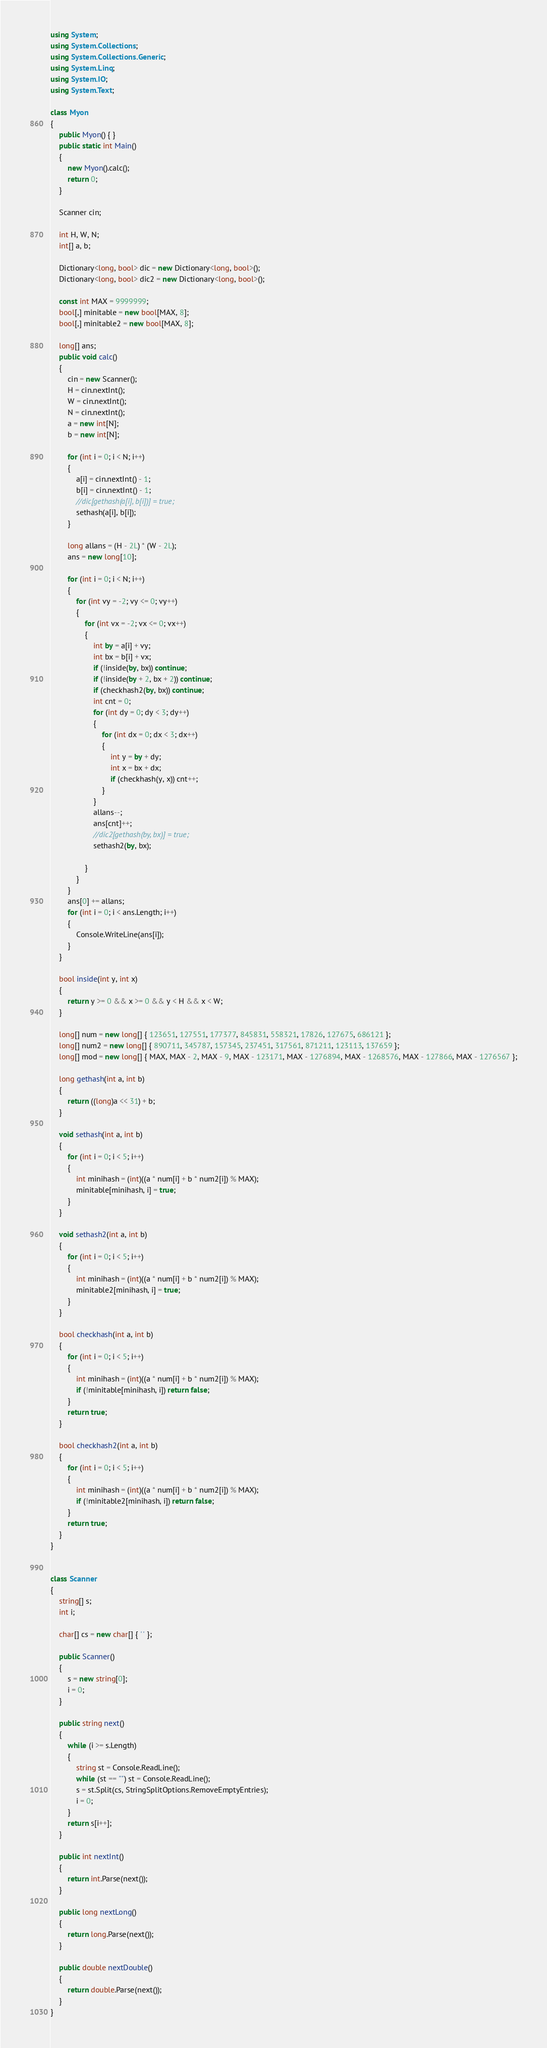Convert code to text. <code><loc_0><loc_0><loc_500><loc_500><_C#_>using System;
using System.Collections;
using System.Collections.Generic;
using System.Linq;
using System.IO;
using System.Text;

class Myon
{
    public Myon() { }
    public static int Main()
    {
        new Myon().calc();
        return 0;
    }

    Scanner cin;

    int H, W, N;
    int[] a, b;

    Dictionary<long, bool> dic = new Dictionary<long, bool>();
    Dictionary<long, bool> dic2 = new Dictionary<long, bool>();

    const int MAX = 9999999;
    bool[,] minitable = new bool[MAX, 8];
    bool[,] minitable2 = new bool[MAX, 8];

    long[] ans;
    public void calc()
    {
        cin = new Scanner();
        H = cin.nextInt();
        W = cin.nextInt();
        N = cin.nextInt();
        a = new int[N];
        b = new int[N];

        for (int i = 0; i < N; i++)
        {
            a[i] = cin.nextInt() - 1;
            b[i] = cin.nextInt() - 1;
            //dic[gethash(a[i], b[i])] = true;
            sethash(a[i], b[i]);
        }

        long allans = (H - 2L) * (W - 2L);
        ans = new long[10];

        for (int i = 0; i < N; i++)
        {
            for (int vy = -2; vy <= 0; vy++)
            {
                for (int vx = -2; vx <= 0; vx++)
                {
                    int by = a[i] + vy;
                    int bx = b[i] + vx;
                    if (!inside(by, bx)) continue;
                    if (!inside(by + 2, bx + 2)) continue;
                    if (checkhash2(by, bx)) continue;
                    int cnt = 0;
                    for (int dy = 0; dy < 3; dy++)
                    {
                        for (int dx = 0; dx < 3; dx++)
                        {
                            int y = by + dy;
                            int x = bx + dx;
                            if (checkhash(y, x)) cnt++;
                        }
                    }
                    allans--;
                    ans[cnt]++;
                    //dic2[gethash(by, bx)] = true;
                    sethash2(by, bx);

                }
            }
        }
        ans[0] += allans;
        for (int i = 0; i < ans.Length; i++)
        {
            Console.WriteLine(ans[i]);
        }
    }

    bool inside(int y, int x)
    {
        return y >= 0 && x >= 0 && y < H && x < W;
    }

    long[] num = new long[] { 123651, 127551, 177377, 845831, 558321, 17826, 127675, 686121 };
    long[] num2 = new long[] { 890711, 345787, 157345, 237451, 317561, 871211, 123113, 137659 };
    long[] mod = new long[] { MAX, MAX - 2, MAX - 9, MAX - 123171, MAX - 1276894, MAX - 1268576, MAX - 127866, MAX - 1276567 };

    long gethash(int a, int b)
    {
        return ((long)a << 31) + b;
    }

    void sethash(int a, int b)
    {
        for (int i = 0; i < 5; i++)
        {
            int minihash = (int)((a * num[i] + b * num2[i]) % MAX);
            minitable[minihash, i] = true;
        }
    }

    void sethash2(int a, int b)
    {
        for (int i = 0; i < 5; i++)
        {
            int minihash = (int)((a * num[i] + b * num2[i]) % MAX);
            minitable2[minihash, i] = true;
        }
    }

    bool checkhash(int a, int b)
    {
        for (int i = 0; i < 5; i++)
        {
            int minihash = (int)((a * num[i] + b * num2[i]) % MAX);
            if (!minitable[minihash, i]) return false;
        }
        return true;
    }

    bool checkhash2(int a, int b)
    {
        for (int i = 0; i < 5; i++)
        {
            int minihash = (int)((a * num[i] + b * num2[i]) % MAX);
            if (!minitable2[minihash, i]) return false;
        }
        return true;
    }
}


class Scanner
{
    string[] s;
    int i;

    char[] cs = new char[] { ' ' };

    public Scanner()
    {
        s = new string[0];
        i = 0;
    }

    public string next()
    {
        while (i >= s.Length)
        {
            string st = Console.ReadLine();
            while (st == "") st = Console.ReadLine();
            s = st.Split(cs, StringSplitOptions.RemoveEmptyEntries);
            i = 0;
        }
        return s[i++];
    }

    public int nextInt()
    {
        return int.Parse(next());
    }

    public long nextLong()
    {
        return long.Parse(next());
    }

    public double nextDouble()
    {
        return double.Parse(next());
    }
}</code> 